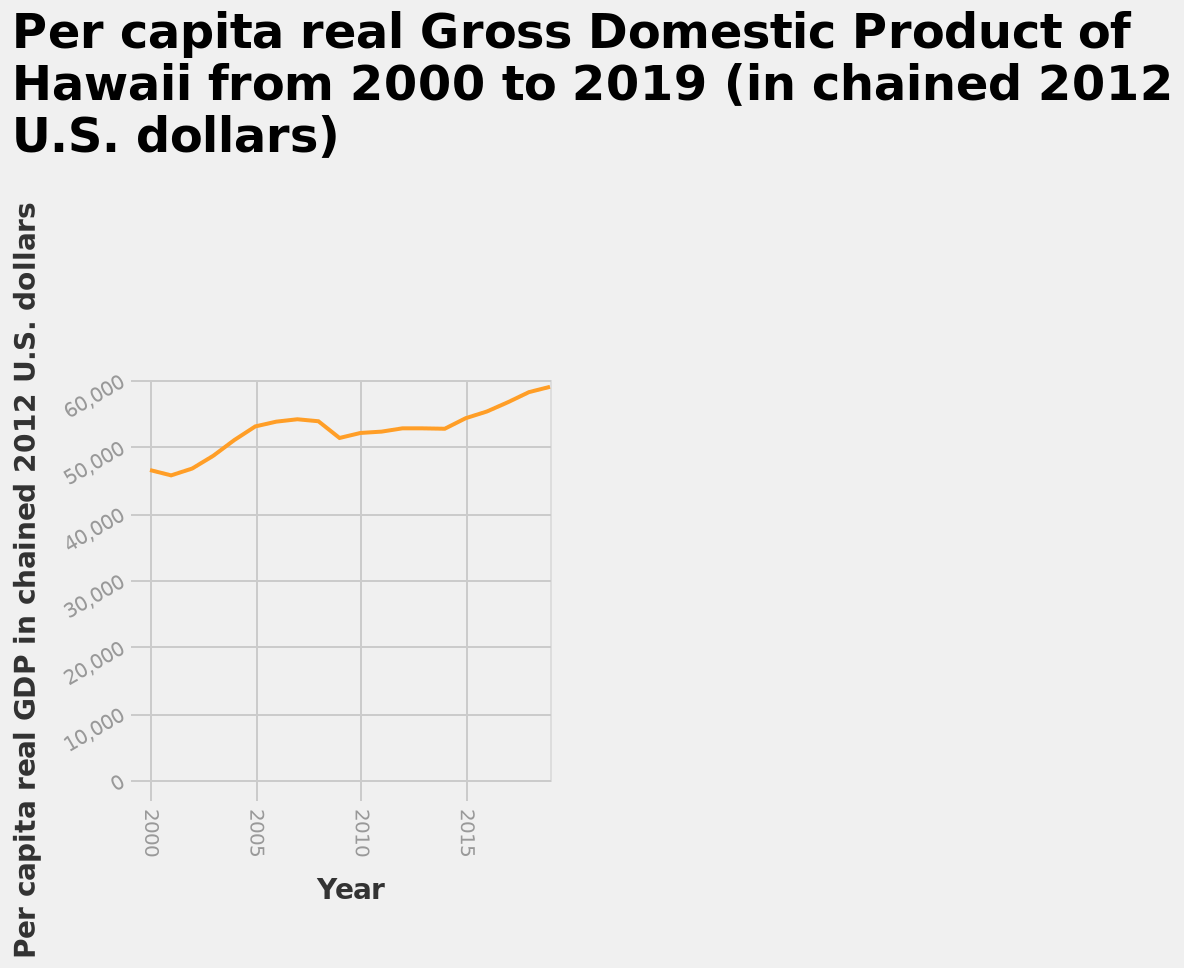<image>
What is represented on the y-axis of the line chart?  The y-axis represents the per capita real Gross Domestic Product (GDP) in chained 2012 U.S. dollars. Was there any exception to the consistent increase in GDP? Yes, there was an exception in approximately 2008 and 2014. What does the line chart visualize?  The line chart visualizes the trend of per capita real GDP of Hawaii from 2000 to 2019. What has been the trend in GDP since 2000? There has been a consistent increase in GDP since 2000. 